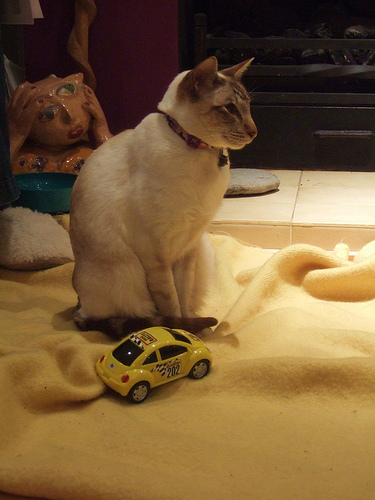How many cats are in the picture? 1 